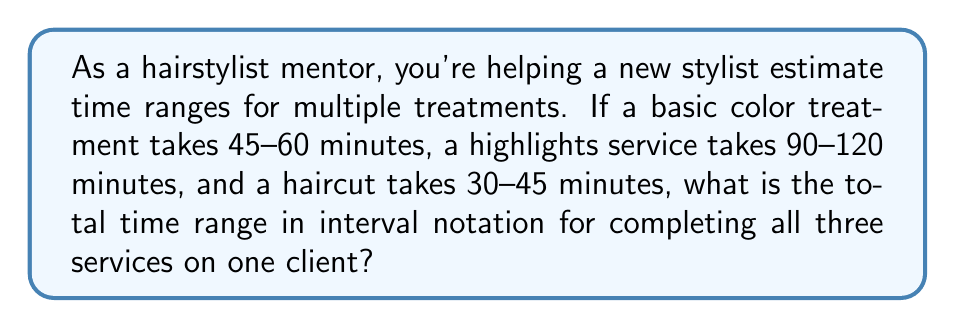Solve this math problem. Let's approach this step-by-step:

1) First, let's identify the time ranges for each service:
   - Basic color: 45-60 minutes
   - Highlights: 90-120 minutes
   - Haircut: 30-45 minutes

2) To find the total time range, we need to add the minimum times and maximum times separately:

   Minimum total time: $45 + 90 + 30 = 165$ minutes
   Maximum total time: $60 + 120 + 45 = 225$ minutes

3) Now we have our range: 165-225 minutes

4) To express this in interval notation, we use square brackets to indicate inclusive endpoints:

   $[165, 225]$

5) However, the question asks for the answer in minutes, so we don't need to convert to hours.
Answer: $[165, 225]$ 